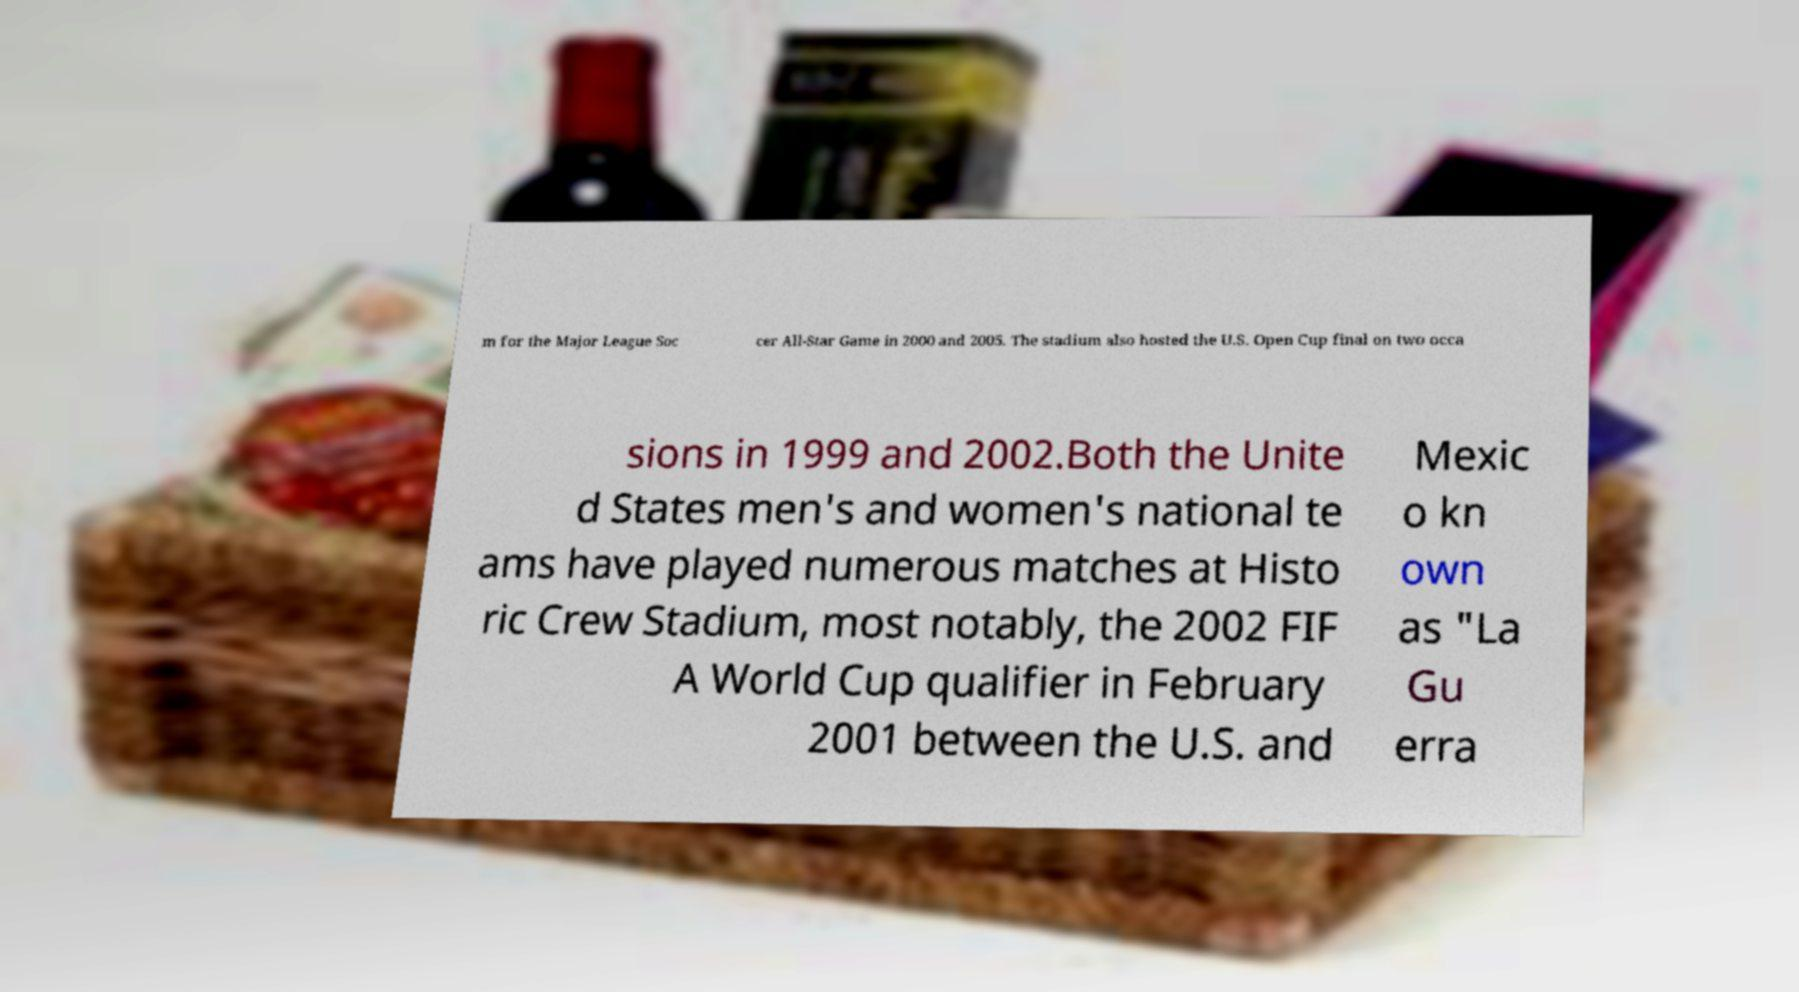I need the written content from this picture converted into text. Can you do that? m for the Major League Soc cer All-Star Game in 2000 and 2005. The stadium also hosted the U.S. Open Cup final on two occa sions in 1999 and 2002.Both the Unite d States men's and women's national te ams have played numerous matches at Histo ric Crew Stadium, most notably, the 2002 FIF A World Cup qualifier in February 2001 between the U.S. and Mexic o kn own as "La Gu erra 